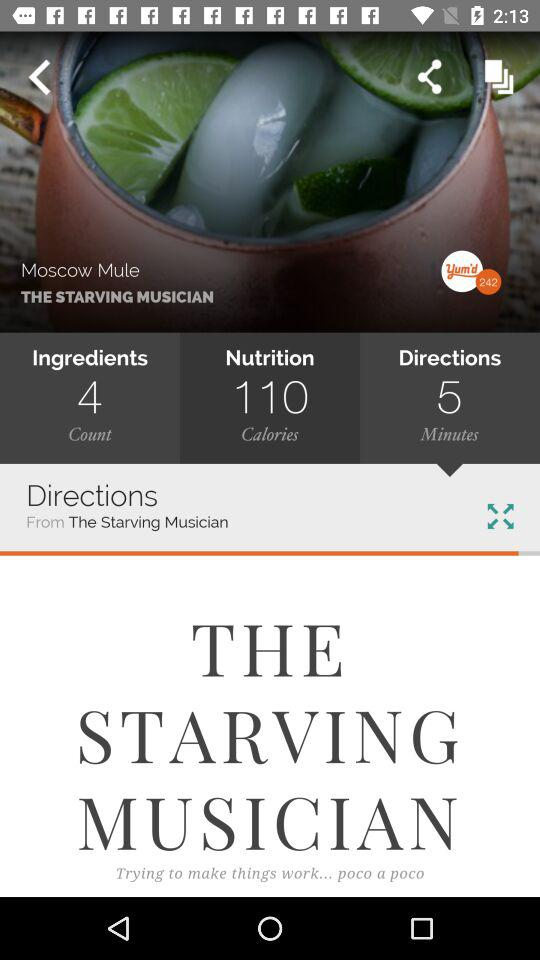What is the dish name? The dish name is "Moscow Mule". 